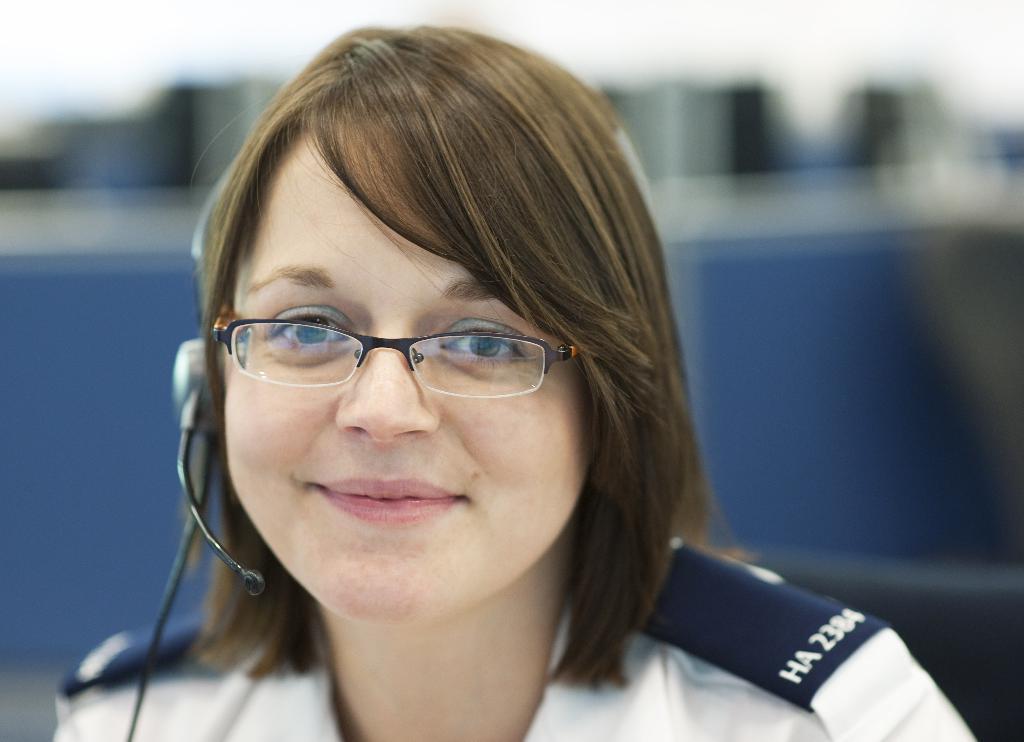Can you describe this image briefly? In this image we can see a woman and the woman is wearing a headphone. The background of the image is blurred. 